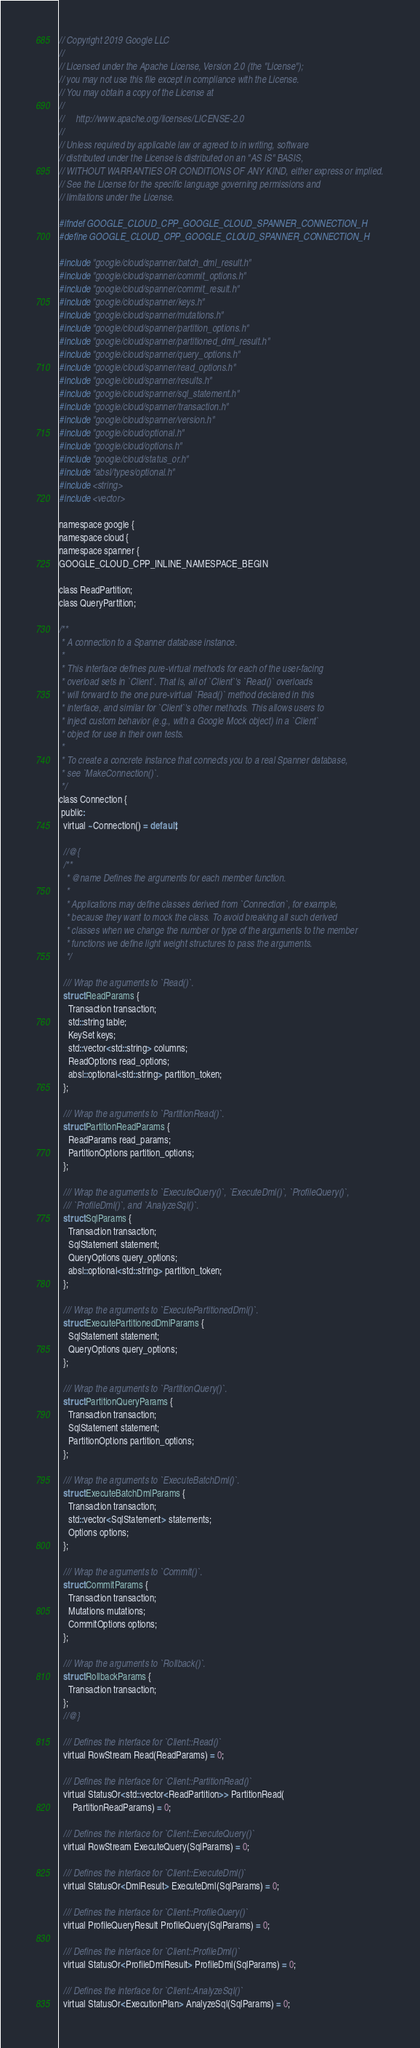<code> <loc_0><loc_0><loc_500><loc_500><_C_>// Copyright 2019 Google LLC
//
// Licensed under the Apache License, Version 2.0 (the "License");
// you may not use this file except in compliance with the License.
// You may obtain a copy of the License at
//
//     http://www.apache.org/licenses/LICENSE-2.0
//
// Unless required by applicable law or agreed to in writing, software
// distributed under the License is distributed on an "AS IS" BASIS,
// WITHOUT WARRANTIES OR CONDITIONS OF ANY KIND, either express or implied.
// See the License for the specific language governing permissions and
// limitations under the License.

#ifndef GOOGLE_CLOUD_CPP_GOOGLE_CLOUD_SPANNER_CONNECTION_H
#define GOOGLE_CLOUD_CPP_GOOGLE_CLOUD_SPANNER_CONNECTION_H

#include "google/cloud/spanner/batch_dml_result.h"
#include "google/cloud/spanner/commit_options.h"
#include "google/cloud/spanner/commit_result.h"
#include "google/cloud/spanner/keys.h"
#include "google/cloud/spanner/mutations.h"
#include "google/cloud/spanner/partition_options.h"
#include "google/cloud/spanner/partitioned_dml_result.h"
#include "google/cloud/spanner/query_options.h"
#include "google/cloud/spanner/read_options.h"
#include "google/cloud/spanner/results.h"
#include "google/cloud/spanner/sql_statement.h"
#include "google/cloud/spanner/transaction.h"
#include "google/cloud/spanner/version.h"
#include "google/cloud/optional.h"
#include "google/cloud/options.h"
#include "google/cloud/status_or.h"
#include "absl/types/optional.h"
#include <string>
#include <vector>

namespace google {
namespace cloud {
namespace spanner {
GOOGLE_CLOUD_CPP_INLINE_NAMESPACE_BEGIN

class ReadPartition;
class QueryPartition;

/**
 * A connection to a Spanner database instance.
 *
 * This interface defines pure-virtual methods for each of the user-facing
 * overload sets in `Client`. That is, all of `Client`'s `Read()` overloads
 * will forward to the one pure-virtual `Read()` method declared in this
 * interface, and similar for `Client`'s other methods. This allows users to
 * inject custom behavior (e.g., with a Google Mock object) in a `Client`
 * object for use in their own tests.
 *
 * To create a concrete instance that connects you to a real Spanner database,
 * see `MakeConnection()`.
 */
class Connection {
 public:
  virtual ~Connection() = default;

  //@{
  /**
   * @name Defines the arguments for each member function.
   *
   * Applications may define classes derived from `Connection`, for example,
   * because they want to mock the class. To avoid breaking all such derived
   * classes when we change the number or type of the arguments to the member
   * functions we define light weight structures to pass the arguments.
   */

  /// Wrap the arguments to `Read()`.
  struct ReadParams {
    Transaction transaction;
    std::string table;
    KeySet keys;
    std::vector<std::string> columns;
    ReadOptions read_options;
    absl::optional<std::string> partition_token;
  };

  /// Wrap the arguments to `PartitionRead()`.
  struct PartitionReadParams {
    ReadParams read_params;
    PartitionOptions partition_options;
  };

  /// Wrap the arguments to `ExecuteQuery()`, `ExecuteDml()`, `ProfileQuery()`,
  /// `ProfileDml()`, and `AnalyzeSql()`.
  struct SqlParams {
    Transaction transaction;
    SqlStatement statement;
    QueryOptions query_options;
    absl::optional<std::string> partition_token;
  };

  /// Wrap the arguments to `ExecutePartitionedDml()`.
  struct ExecutePartitionedDmlParams {
    SqlStatement statement;
    QueryOptions query_options;
  };

  /// Wrap the arguments to `PartitionQuery()`.
  struct PartitionQueryParams {
    Transaction transaction;
    SqlStatement statement;
    PartitionOptions partition_options;
  };

  /// Wrap the arguments to `ExecuteBatchDml()`.
  struct ExecuteBatchDmlParams {
    Transaction transaction;
    std::vector<SqlStatement> statements;
    Options options;
  };

  /// Wrap the arguments to `Commit()`.
  struct CommitParams {
    Transaction transaction;
    Mutations mutations;
    CommitOptions options;
  };

  /// Wrap the arguments to `Rollback()`.
  struct RollbackParams {
    Transaction transaction;
  };
  //@}

  /// Defines the interface for `Client::Read()`
  virtual RowStream Read(ReadParams) = 0;

  /// Defines the interface for `Client::PartitionRead()`
  virtual StatusOr<std::vector<ReadPartition>> PartitionRead(
      PartitionReadParams) = 0;

  /// Defines the interface for `Client::ExecuteQuery()`
  virtual RowStream ExecuteQuery(SqlParams) = 0;

  /// Defines the interface for `Client::ExecuteDml()`
  virtual StatusOr<DmlResult> ExecuteDml(SqlParams) = 0;

  /// Defines the interface for `Client::ProfileQuery()`
  virtual ProfileQueryResult ProfileQuery(SqlParams) = 0;

  /// Defines the interface for `Client::ProfileDml()`
  virtual StatusOr<ProfileDmlResult> ProfileDml(SqlParams) = 0;

  /// Defines the interface for `Client::AnalyzeSql()`
  virtual StatusOr<ExecutionPlan> AnalyzeSql(SqlParams) = 0;
</code> 